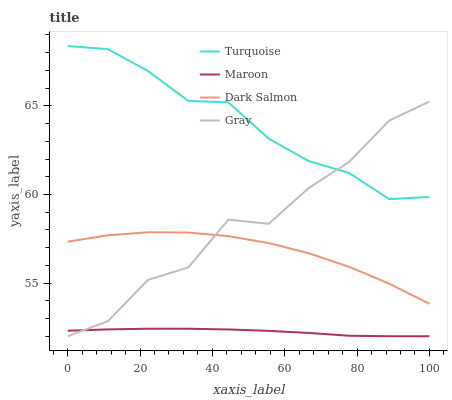Does Maroon have the minimum area under the curve?
Answer yes or no. Yes. Does Dark Salmon have the minimum area under the curve?
Answer yes or no. No. Does Dark Salmon have the maximum area under the curve?
Answer yes or no. No. Is Maroon the smoothest?
Answer yes or no. Yes. Is Gray the roughest?
Answer yes or no. Yes. Is Turquoise the smoothest?
Answer yes or no. No. Is Turquoise the roughest?
Answer yes or no. No. Does Dark Salmon have the lowest value?
Answer yes or no. No. Does Dark Salmon have the highest value?
Answer yes or no. No. Is Dark Salmon less than Turquoise?
Answer yes or no. Yes. Is Turquoise greater than Dark Salmon?
Answer yes or no. Yes. Does Dark Salmon intersect Turquoise?
Answer yes or no. No. 